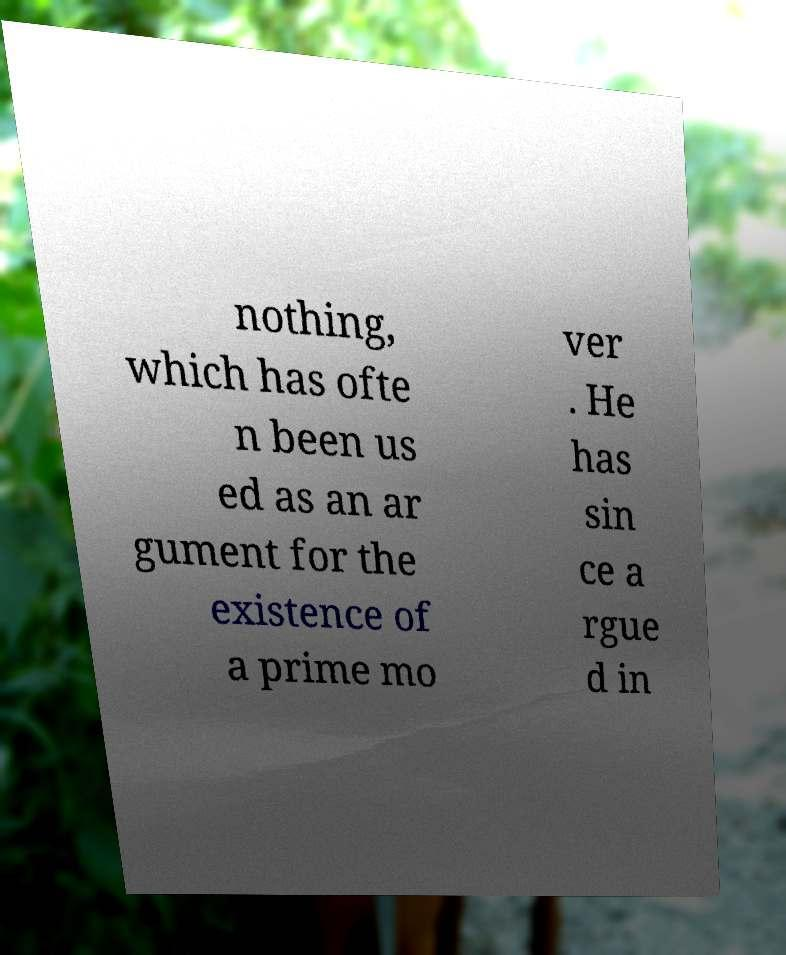For documentation purposes, I need the text within this image transcribed. Could you provide that? nothing, which has ofte n been us ed as an ar gument for the existence of a prime mo ver . He has sin ce a rgue d in 